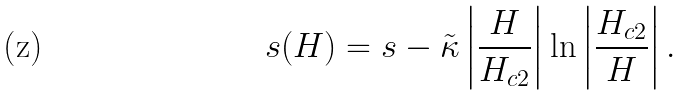Convert formula to latex. <formula><loc_0><loc_0><loc_500><loc_500>s ( H ) = s - \tilde { \kappa } \left | \frac { H } { H _ { c 2 } } \right | \ln \left | \frac { H _ { c 2 } } { H } \right | .</formula> 